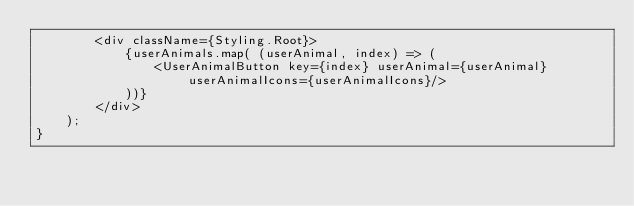Convert code to text. <code><loc_0><loc_0><loc_500><loc_500><_JavaScript_>        <div className={Styling.Root}>
            {userAnimals.map( (userAnimal, index) => (
                <UserAnimalButton key={index} userAnimal={userAnimal} userAnimalIcons={userAnimalIcons}/>
            ))}
        </div>
    );
}
</code> 